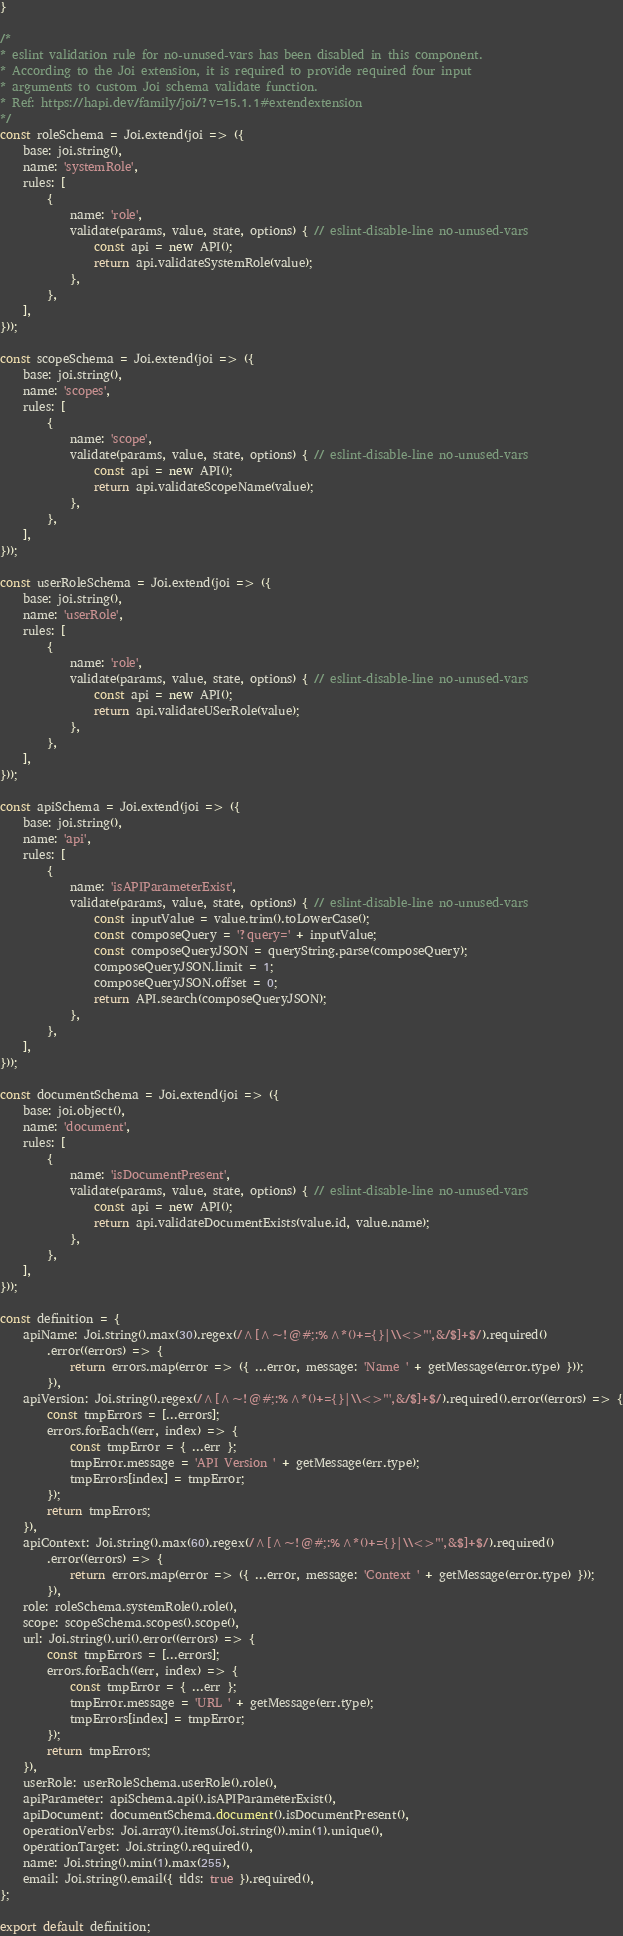<code> <loc_0><loc_0><loc_500><loc_500><_JavaScript_>}

/*
* eslint validation rule for no-unused-vars has been disabled in this component.
* According to the Joi extension, it is required to provide required four input
* arguments to custom Joi schema validate function.
* Ref: https://hapi.dev/family/joi/?v=15.1.1#extendextension
*/
const roleSchema = Joi.extend(joi => ({
    base: joi.string(),
    name: 'systemRole',
    rules: [
        {
            name: 'role',
            validate(params, value, state, options) { // eslint-disable-line no-unused-vars
                const api = new API();
                return api.validateSystemRole(value);
            },
        },
    ],
}));

const scopeSchema = Joi.extend(joi => ({
    base: joi.string(),
    name: 'scopes',
    rules: [
        {
            name: 'scope',
            validate(params, value, state, options) { // eslint-disable-line no-unused-vars
                const api = new API();
                return api.validateScopeName(value);
            },
        },
    ],
}));

const userRoleSchema = Joi.extend(joi => ({
    base: joi.string(),
    name: 'userRole',
    rules: [
        {
            name: 'role',
            validate(params, value, state, options) { // eslint-disable-line no-unused-vars
                const api = new API();
                return api.validateUSerRole(value);
            },
        },
    ],
}));

const apiSchema = Joi.extend(joi => ({
    base: joi.string(),
    name: 'api',
    rules: [
        {
            name: 'isAPIParameterExist',
            validate(params, value, state, options) { // eslint-disable-line no-unused-vars
                const inputValue = value.trim().toLowerCase();
                const composeQuery = '?query=' + inputValue;
                const composeQueryJSON = queryString.parse(composeQuery);
                composeQueryJSON.limit = 1;
                composeQueryJSON.offset = 0;
                return API.search(composeQueryJSON);
            },
        },
    ],
}));

const documentSchema = Joi.extend(joi => ({
    base: joi.object(),
    name: 'document',
    rules: [
        {
            name: 'isDocumentPresent',
            validate(params, value, state, options) { // eslint-disable-line no-unused-vars
                const api = new API();
                return api.validateDocumentExists(value.id, value.name);
            },
        },
    ],
}));

const definition = {
    apiName: Joi.string().max(30).regex(/^[^~!@#;:%^*()+={}|\\<>"',&/$]+$/).required()
        .error((errors) => {
            return errors.map(error => ({ ...error, message: 'Name ' + getMessage(error.type) }));
        }),
    apiVersion: Joi.string().regex(/^[^~!@#;:%^*()+={}|\\<>"',&/$]+$/).required().error((errors) => {
        const tmpErrors = [...errors];
        errors.forEach((err, index) => {
            const tmpError = { ...err };
            tmpError.message = 'API Version ' + getMessage(err.type);
            tmpErrors[index] = tmpError;
        });
        return tmpErrors;
    }),
    apiContext: Joi.string().max(60).regex(/^[^~!@#;:%^*()+={}|\\<>"',&$]+$/).required()
        .error((errors) => {
            return errors.map(error => ({ ...error, message: 'Context ' + getMessage(error.type) }));
        }),
    role: roleSchema.systemRole().role(),
    scope: scopeSchema.scopes().scope(),
    url: Joi.string().uri().error((errors) => {
        const tmpErrors = [...errors];
        errors.forEach((err, index) => {
            const tmpError = { ...err };
            tmpError.message = 'URL ' + getMessage(err.type);
            tmpErrors[index] = tmpError;
        });
        return tmpErrors;
    }),
    userRole: userRoleSchema.userRole().role(),
    apiParameter: apiSchema.api().isAPIParameterExist(),
    apiDocument: documentSchema.document().isDocumentPresent(),
    operationVerbs: Joi.array().items(Joi.string()).min(1).unique(),
    operationTarget: Joi.string().required(),
    name: Joi.string().min(1).max(255),
    email: Joi.string().email({ tlds: true }).required(),
};

export default definition;
</code> 